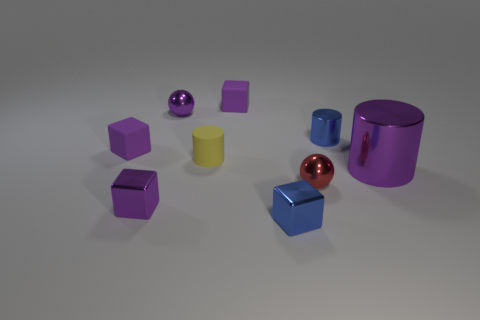What color is the metal cylinder behind the large metal cylinder that is behind the small red metal object?
Provide a short and direct response. Blue. There is a metallic cylinder that is the same size as the red metallic thing; what color is it?
Ensure brevity in your answer.  Blue. What number of rubber objects are either small spheres or blocks?
Keep it short and to the point. 2. There is a small blue object that is in front of the red sphere; how many small red metallic objects are in front of it?
Your answer should be very brief. 0. What is the size of the metal object that is the same color as the small shiny cylinder?
Give a very brief answer. Small. What number of things are tiny metal cylinders or purple metallic objects in front of the big purple metal cylinder?
Keep it short and to the point. 2. Are there any tiny purple balls that have the same material as the tiny blue block?
Keep it short and to the point. Yes. How many things are both on the left side of the purple metallic sphere and to the right of the tiny red object?
Offer a very short reply. 0. There is a tiny blue thing in front of the tiny purple metallic cube; what material is it?
Give a very brief answer. Metal. There is a red sphere that is the same material as the big purple object; what is its size?
Offer a very short reply. Small. 